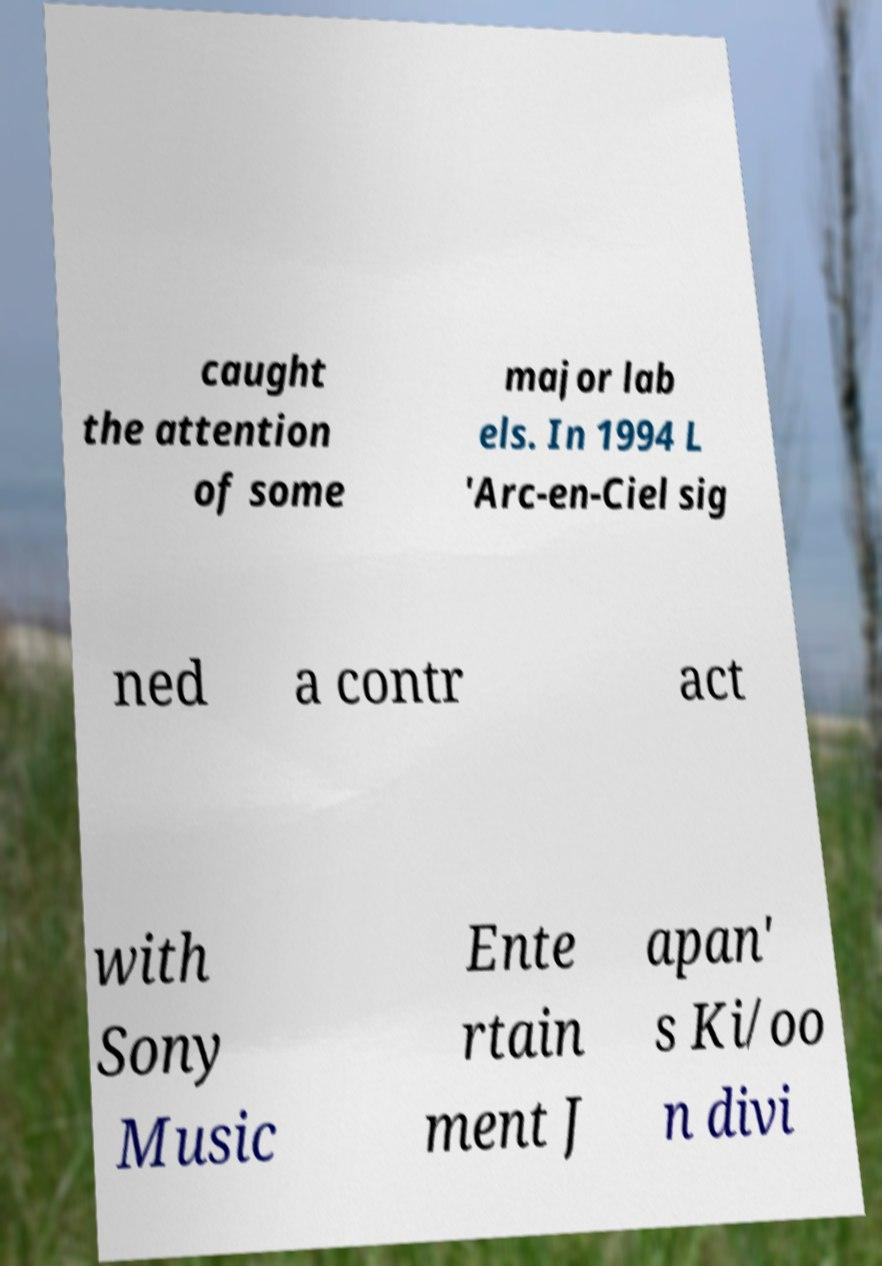Please read and relay the text visible in this image. What does it say? caught the attention of some major lab els. In 1994 L 'Arc-en-Ciel sig ned a contr act with Sony Music Ente rtain ment J apan' s Ki/oo n divi 